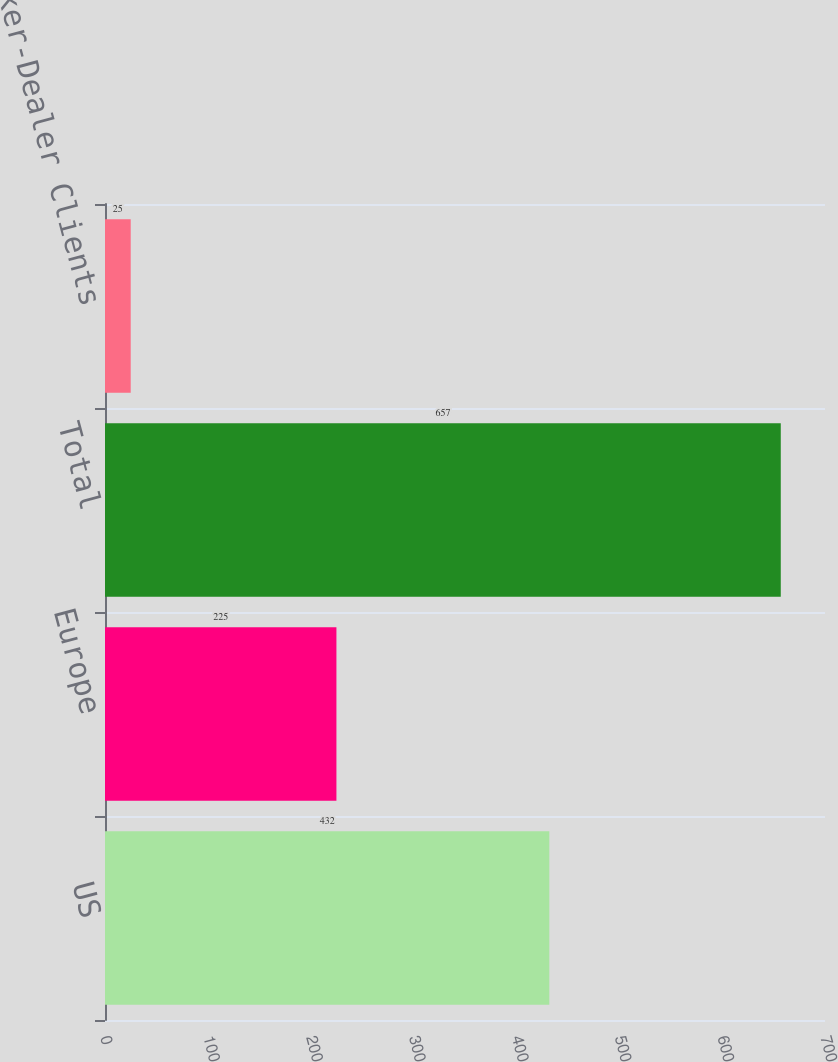<chart> <loc_0><loc_0><loc_500><loc_500><bar_chart><fcel>US<fcel>Europe<fcel>Total<fcel>Broker-Dealer Clients<nl><fcel>432<fcel>225<fcel>657<fcel>25<nl></chart> 